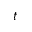<formula> <loc_0><loc_0><loc_500><loc_500>t</formula> 